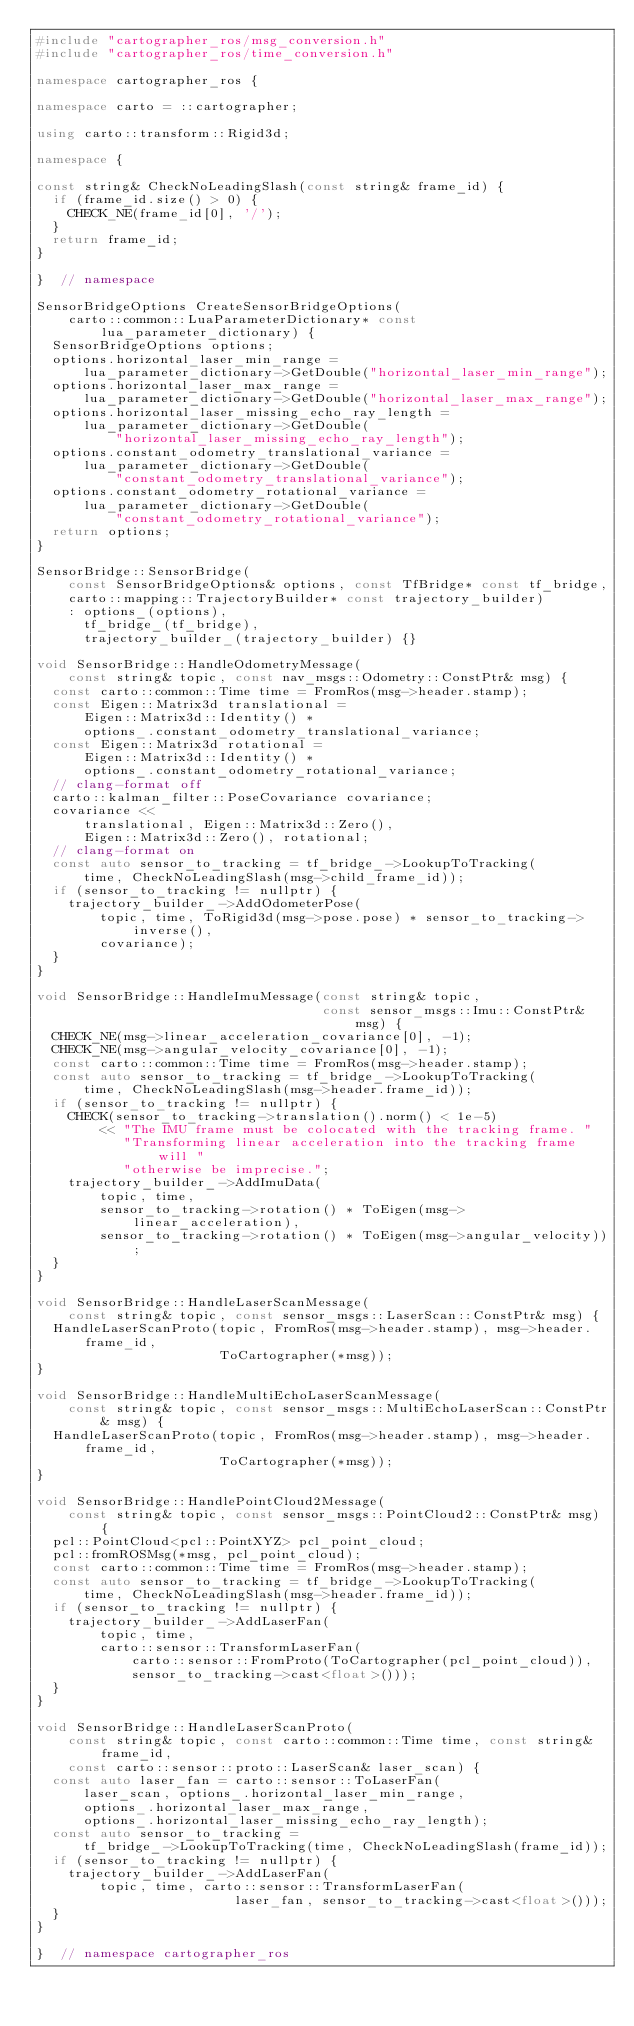Convert code to text. <code><loc_0><loc_0><loc_500><loc_500><_C++_>#include "cartographer_ros/msg_conversion.h"
#include "cartographer_ros/time_conversion.h"

namespace cartographer_ros {

namespace carto = ::cartographer;

using carto::transform::Rigid3d;

namespace {

const string& CheckNoLeadingSlash(const string& frame_id) {
  if (frame_id.size() > 0) {
    CHECK_NE(frame_id[0], '/');
  }
  return frame_id;
}

}  // namespace

SensorBridgeOptions CreateSensorBridgeOptions(
    carto::common::LuaParameterDictionary* const lua_parameter_dictionary) {
  SensorBridgeOptions options;
  options.horizontal_laser_min_range =
      lua_parameter_dictionary->GetDouble("horizontal_laser_min_range");
  options.horizontal_laser_max_range =
      lua_parameter_dictionary->GetDouble("horizontal_laser_max_range");
  options.horizontal_laser_missing_echo_ray_length =
      lua_parameter_dictionary->GetDouble(
          "horizontal_laser_missing_echo_ray_length");
  options.constant_odometry_translational_variance =
      lua_parameter_dictionary->GetDouble(
          "constant_odometry_translational_variance");
  options.constant_odometry_rotational_variance =
      lua_parameter_dictionary->GetDouble(
          "constant_odometry_rotational_variance");
  return options;
}

SensorBridge::SensorBridge(
    const SensorBridgeOptions& options, const TfBridge* const tf_bridge,
    carto::mapping::TrajectoryBuilder* const trajectory_builder)
    : options_(options),
      tf_bridge_(tf_bridge),
      trajectory_builder_(trajectory_builder) {}

void SensorBridge::HandleOdometryMessage(
    const string& topic, const nav_msgs::Odometry::ConstPtr& msg) {
  const carto::common::Time time = FromRos(msg->header.stamp);
  const Eigen::Matrix3d translational =
      Eigen::Matrix3d::Identity() *
      options_.constant_odometry_translational_variance;
  const Eigen::Matrix3d rotational =
      Eigen::Matrix3d::Identity() *
      options_.constant_odometry_rotational_variance;
  // clang-format off
  carto::kalman_filter::PoseCovariance covariance;
  covariance <<
      translational, Eigen::Matrix3d::Zero(),
      Eigen::Matrix3d::Zero(), rotational;
  // clang-format on
  const auto sensor_to_tracking = tf_bridge_->LookupToTracking(
      time, CheckNoLeadingSlash(msg->child_frame_id));
  if (sensor_to_tracking != nullptr) {
    trajectory_builder_->AddOdometerPose(
        topic, time, ToRigid3d(msg->pose.pose) * sensor_to_tracking->inverse(),
        covariance);
  }
}

void SensorBridge::HandleImuMessage(const string& topic,
                                    const sensor_msgs::Imu::ConstPtr& msg) {
  CHECK_NE(msg->linear_acceleration_covariance[0], -1);
  CHECK_NE(msg->angular_velocity_covariance[0], -1);
  const carto::common::Time time = FromRos(msg->header.stamp);
  const auto sensor_to_tracking = tf_bridge_->LookupToTracking(
      time, CheckNoLeadingSlash(msg->header.frame_id));
  if (sensor_to_tracking != nullptr) {
    CHECK(sensor_to_tracking->translation().norm() < 1e-5)
        << "The IMU frame must be colocated with the tracking frame. "
           "Transforming linear acceleration into the tracking frame will "
           "otherwise be imprecise.";
    trajectory_builder_->AddImuData(
        topic, time,
        sensor_to_tracking->rotation() * ToEigen(msg->linear_acceleration),
        sensor_to_tracking->rotation() * ToEigen(msg->angular_velocity));
  }
}

void SensorBridge::HandleLaserScanMessage(
    const string& topic, const sensor_msgs::LaserScan::ConstPtr& msg) {
  HandleLaserScanProto(topic, FromRos(msg->header.stamp), msg->header.frame_id,
                       ToCartographer(*msg));
}

void SensorBridge::HandleMultiEchoLaserScanMessage(
    const string& topic, const sensor_msgs::MultiEchoLaserScan::ConstPtr& msg) {
  HandleLaserScanProto(topic, FromRos(msg->header.stamp), msg->header.frame_id,
                       ToCartographer(*msg));
}

void SensorBridge::HandlePointCloud2Message(
    const string& topic, const sensor_msgs::PointCloud2::ConstPtr& msg) {
  pcl::PointCloud<pcl::PointXYZ> pcl_point_cloud;
  pcl::fromROSMsg(*msg, pcl_point_cloud);
  const carto::common::Time time = FromRos(msg->header.stamp);
  const auto sensor_to_tracking = tf_bridge_->LookupToTracking(
      time, CheckNoLeadingSlash(msg->header.frame_id));
  if (sensor_to_tracking != nullptr) {
    trajectory_builder_->AddLaserFan(
        topic, time,
        carto::sensor::TransformLaserFan(
            carto::sensor::FromProto(ToCartographer(pcl_point_cloud)),
            sensor_to_tracking->cast<float>()));
  }
}

void SensorBridge::HandleLaserScanProto(
    const string& topic, const carto::common::Time time, const string& frame_id,
    const carto::sensor::proto::LaserScan& laser_scan) {
  const auto laser_fan = carto::sensor::ToLaserFan(
      laser_scan, options_.horizontal_laser_min_range,
      options_.horizontal_laser_max_range,
      options_.horizontal_laser_missing_echo_ray_length);
  const auto sensor_to_tracking =
      tf_bridge_->LookupToTracking(time, CheckNoLeadingSlash(frame_id));
  if (sensor_to_tracking != nullptr) {
    trajectory_builder_->AddLaserFan(
        topic, time, carto::sensor::TransformLaserFan(
                         laser_fan, sensor_to_tracking->cast<float>()));
  }
}

}  // namespace cartographer_ros
</code> 